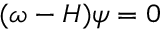Convert formula to latex. <formula><loc_0><loc_0><loc_500><loc_500>\begin{array} { r } { ( \omega - H ) \psi = 0 } \end{array}</formula> 